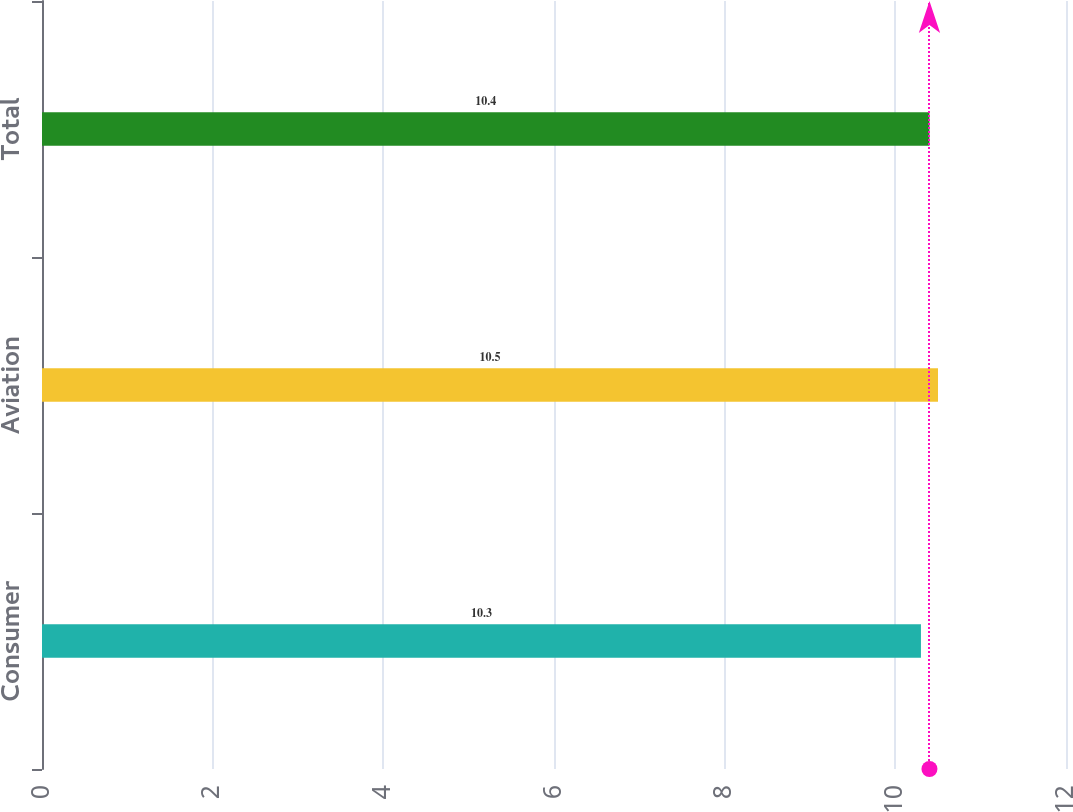Convert chart. <chart><loc_0><loc_0><loc_500><loc_500><bar_chart><fcel>Consumer<fcel>Aviation<fcel>Total<nl><fcel>10.3<fcel>10.5<fcel>10.4<nl></chart> 